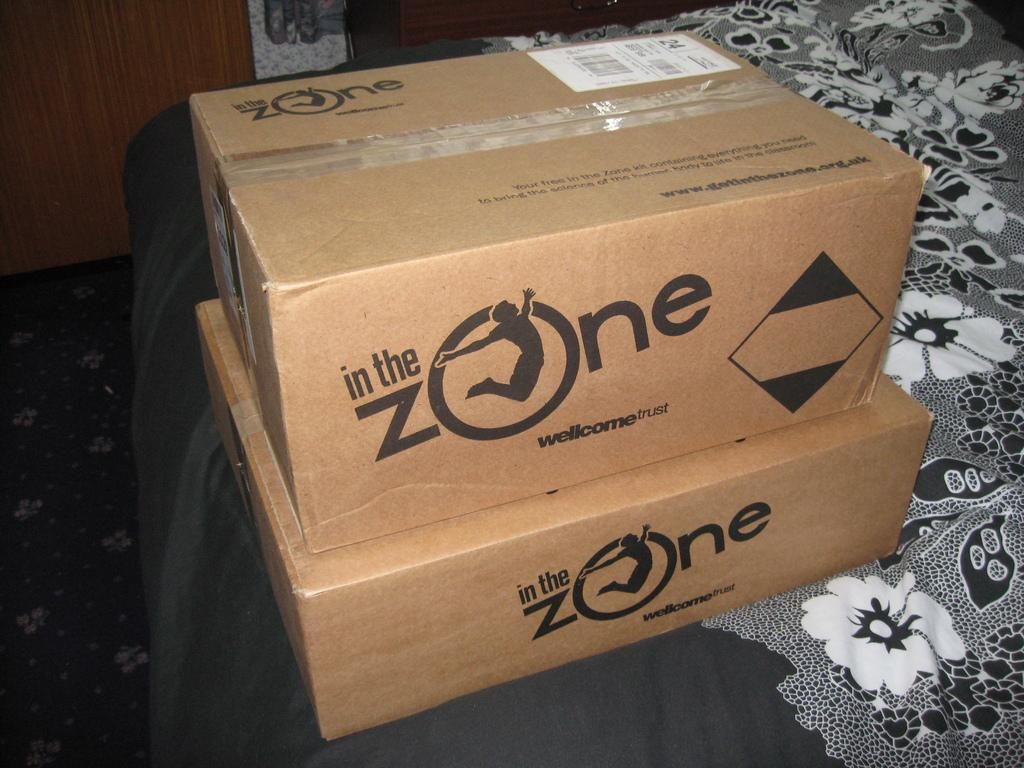<image>
Render a clear and concise summary of the photo. Two boxes are stacked on top of each other that are labeled In the Zone. 